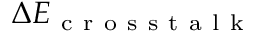<formula> <loc_0><loc_0><loc_500><loc_500>\Delta E _ { c r o s s t a l k }</formula> 